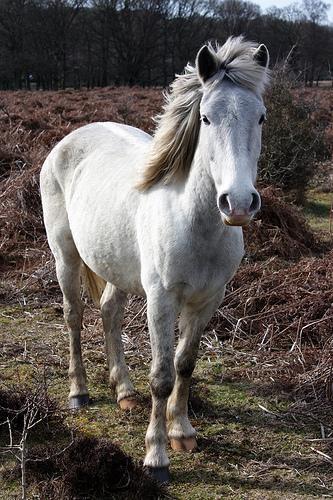How many horses are there?
Give a very brief answer. 1. How many hooves are shown?
Give a very brief answer. 4. 